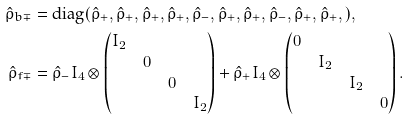Convert formula to latex. <formula><loc_0><loc_0><loc_500><loc_500>\hat { \rho } _ { b \mp } & = \text {diag} ( \hat { \rho } _ { + } , \hat { \rho } _ { + } , \hat { \rho } _ { + } , \hat { \rho } _ { + } , \hat { \rho } _ { - } , \hat { \rho } _ { + } , \hat { \rho } _ { + } , \hat { \rho } _ { - } , \hat { \rho } _ { + } , \hat { \rho } _ { + } , ) , \\ \hat { \rho } _ { f \mp } & = \hat { \rho } _ { - } I _ { 4 } \otimes \begin{pmatrix} I _ { 2 } & & & \\ & 0 & & \\ & & 0 & \\ & & & I _ { 2 } \end{pmatrix} + \hat { \rho } _ { + } I _ { 4 } \otimes \begin{pmatrix} 0 & & & \\ & I _ { 2 } & & \\ & & I _ { 2 } & \\ & & & 0 \end{pmatrix} .</formula> 